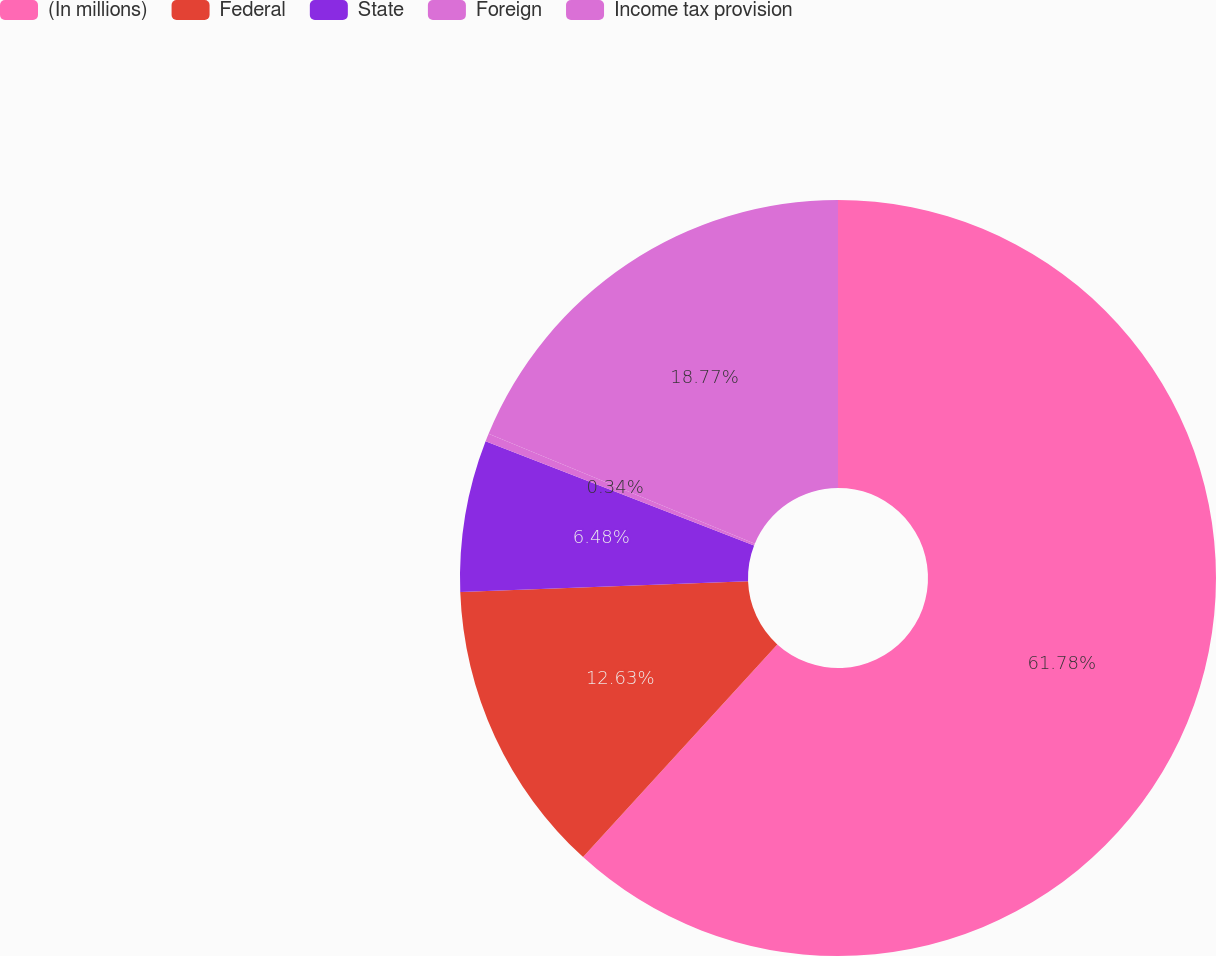Convert chart to OTSL. <chart><loc_0><loc_0><loc_500><loc_500><pie_chart><fcel>(In millions)<fcel>Federal<fcel>State<fcel>Foreign<fcel>Income tax provision<nl><fcel>61.78%<fcel>12.63%<fcel>6.48%<fcel>0.34%<fcel>18.77%<nl></chart> 